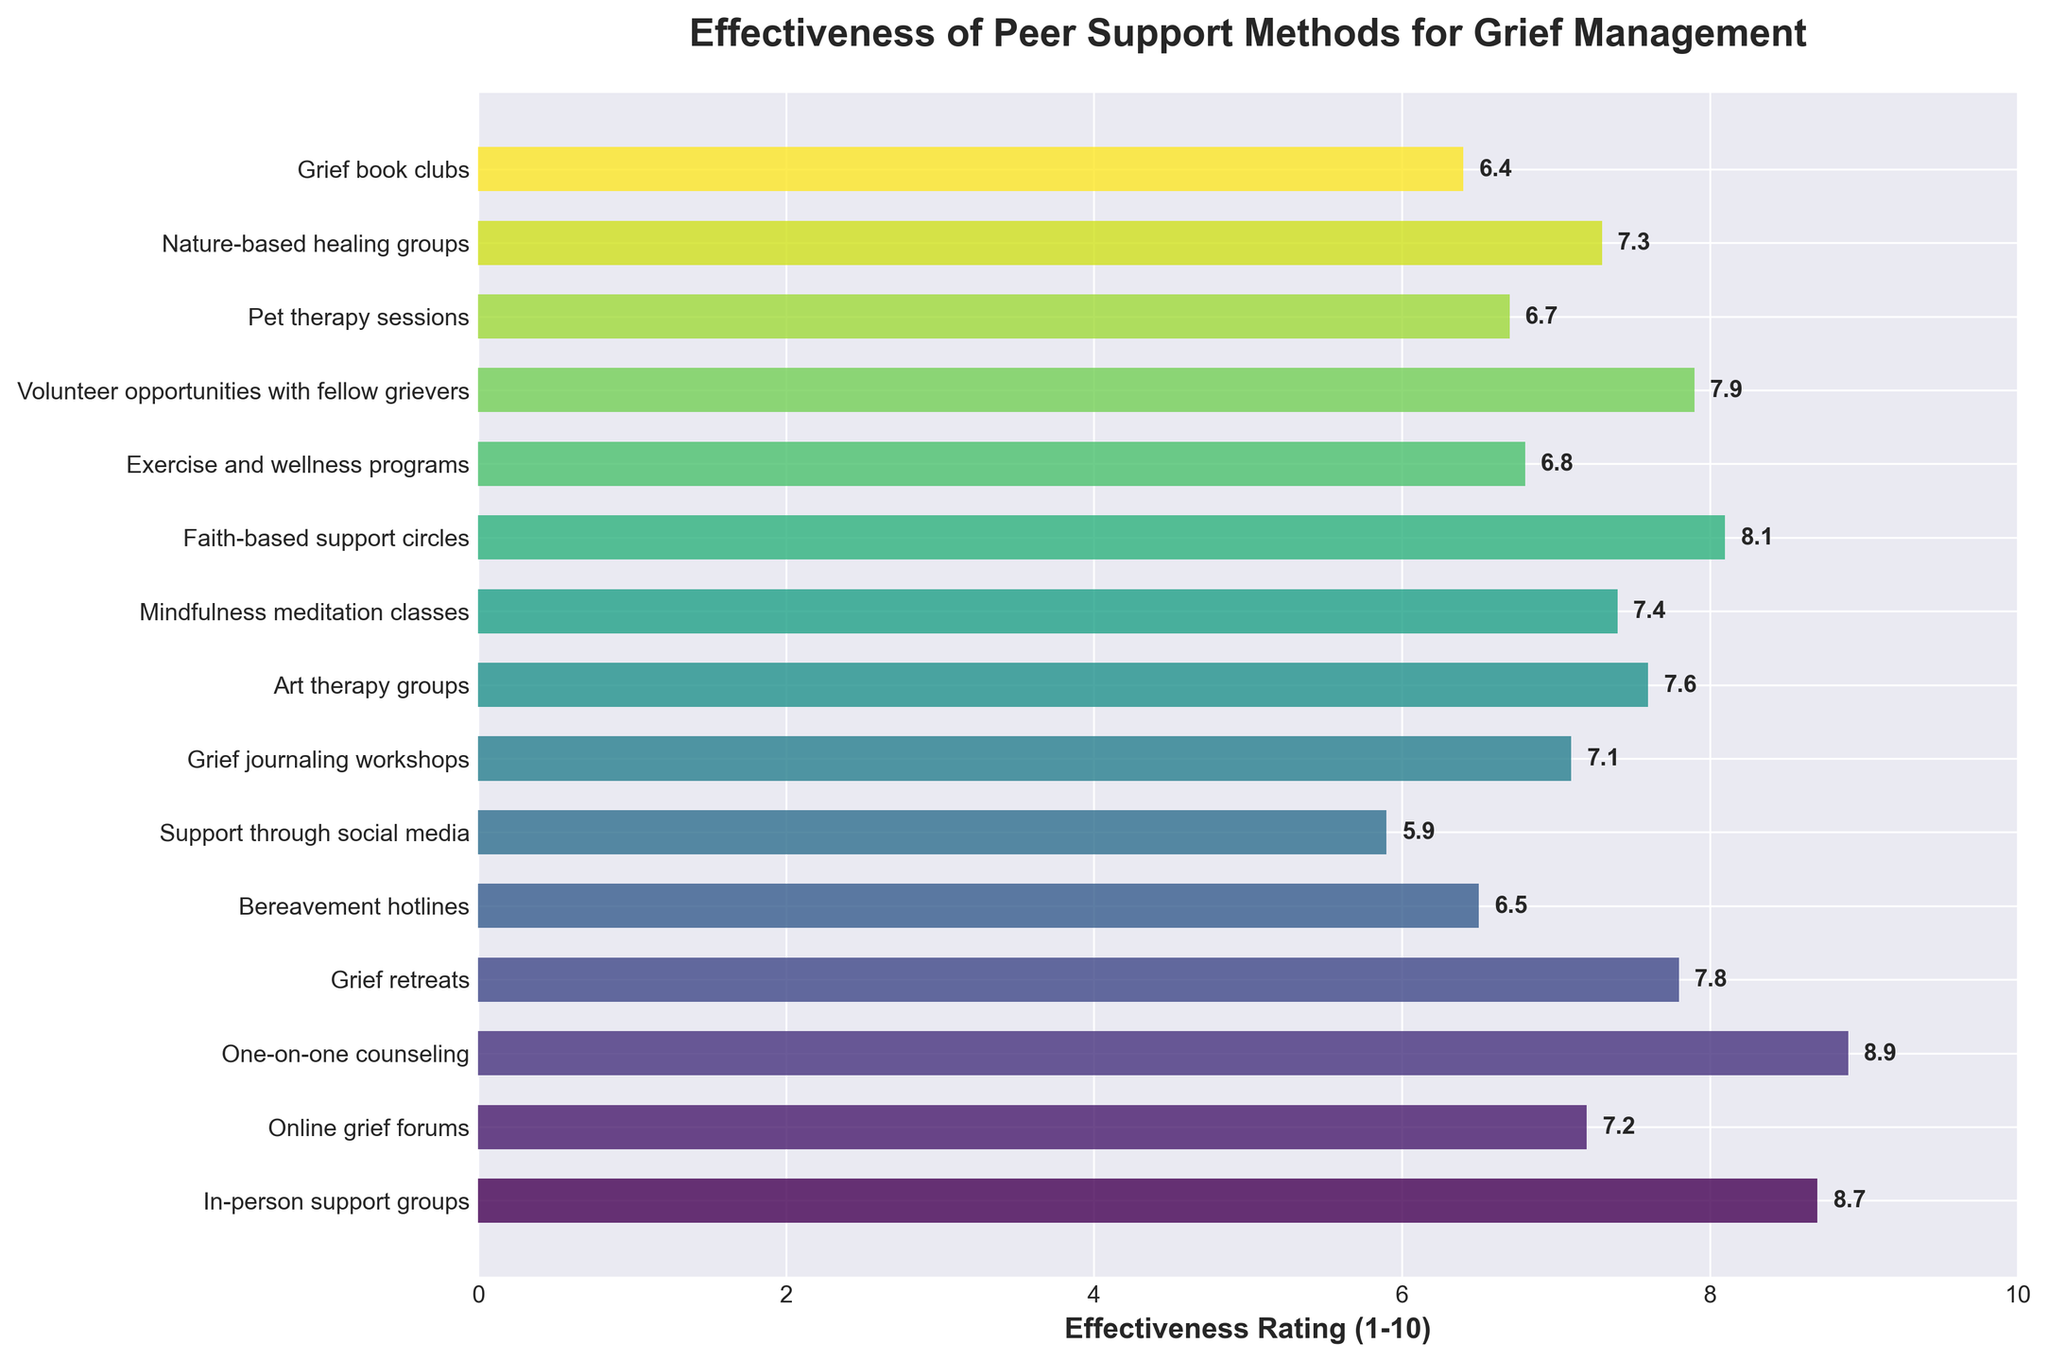Which peer support method has the highest effectiveness rating? By examining the horizontal bars, the longest bar represents the highest effectiveness rating. It corresponds to "One-on-one counseling" with an effectiveness rating of 8.9.
Answer: One-on-one counseling Which peer support method has the lowest effectiveness rating? By examining the shortest horizontal bar, it represents the lowest effectiveness rating. It corresponds to "Grief book clubs" with an effectiveness rating of 6.4.
Answer: Grief book clubs How much higher is the effectiveness rating of "In-person support groups" compared to "Support through social media"? The effectiveness rating of "In-person support groups" is 8.7, while "Support through social media" rates 5.9. The difference is 8.7 - 5.9 = 2.8.
Answer: 2.8 What is the average effectiveness rating of the methods listed? Sum all the effectiveness ratings and then divide by the number of methods. The sum is 114.3, and with 15 methods, the average is 114.3 ÷ 15 ≈ 7.62.
Answer: 7.62 Which peer support methods have ratings higher than 8? By looking at the bars with ratings above 8, they are "In-person support groups" (8.7), "One-on-one counseling" (8.9), and "Faith-based support circles" (8.1).
Answer: In-person support groups, One-on-one counseling, Faith-based support circles How many peer support methods have an effectiveness rating below 7? Counting the bars that have ratings below 7, they are "Bereavement hotlines" (6.5), "Support through social media" (5.9), "Pet therapy sessions" (6.7), and "Grief book clubs" (6.4), which totals to 4.
Answer: 4 What is the combined effectiveness rating of "Grief journaling workshops" and "Art therapy groups"? Adding the effectiveness ratings of "Grief journaling workshops" (7.1) and "Art therapy groups" (7.6) results in 7.1 + 7.6 = 14.7.
Answer: 14.7 Is "Mindfulness meditation classes" rated higher or lower than "Exercise and wellness programs"? The rating for "Mindfulness meditation classes" is 7.4, whereas "Exercise and wellness programs" has a rating of 6.8. Thus, "Mindfulness meditation classes" is rated higher.
Answer: Higher Which method is rated closer to the average effectiveness rating of all methods? The average effectiveness rating is 7.62. "Volunteer opportunities with fellow grievers" has a rating of 7.9, which is closest to the average of 7.62.
Answer: Volunteer opportunities with fellow grievers 